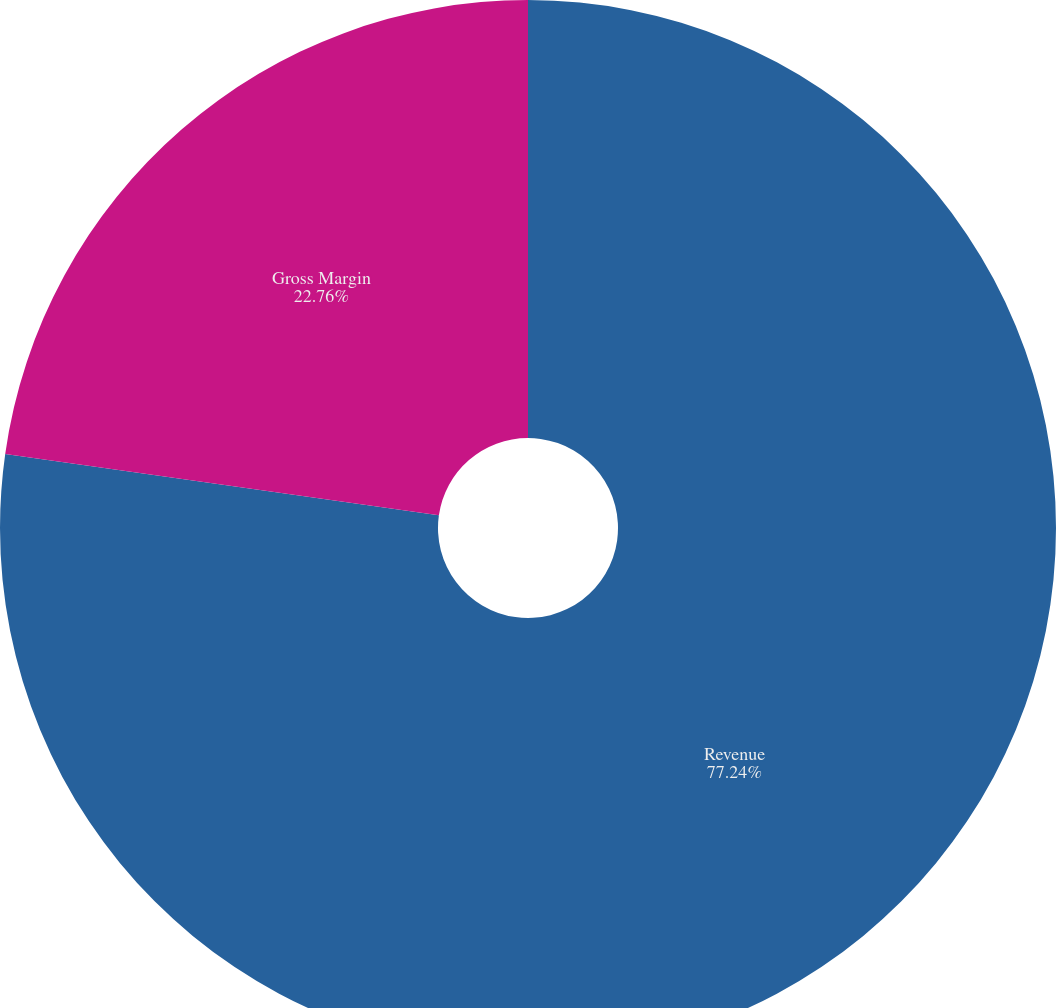Convert chart to OTSL. <chart><loc_0><loc_0><loc_500><loc_500><pie_chart><fcel>Revenue<fcel>Gross Margin<nl><fcel>77.24%<fcel>22.76%<nl></chart> 